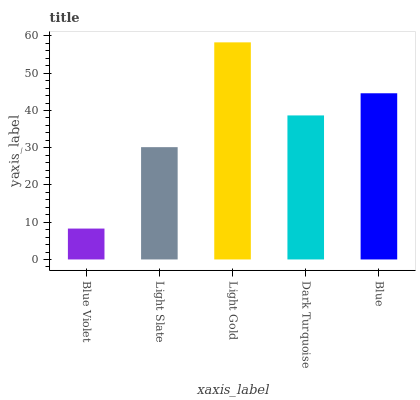Is Blue Violet the minimum?
Answer yes or no. Yes. Is Light Gold the maximum?
Answer yes or no. Yes. Is Light Slate the minimum?
Answer yes or no. No. Is Light Slate the maximum?
Answer yes or no. No. Is Light Slate greater than Blue Violet?
Answer yes or no. Yes. Is Blue Violet less than Light Slate?
Answer yes or no. Yes. Is Blue Violet greater than Light Slate?
Answer yes or no. No. Is Light Slate less than Blue Violet?
Answer yes or no. No. Is Dark Turquoise the high median?
Answer yes or no. Yes. Is Dark Turquoise the low median?
Answer yes or no. Yes. Is Light Gold the high median?
Answer yes or no. No. Is Blue Violet the low median?
Answer yes or no. No. 